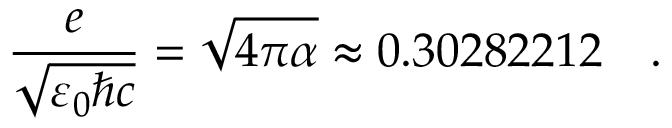<formula> <loc_0><loc_0><loc_500><loc_500>{ \frac { e } { \sqrt { \varepsilon _ { 0 } \hbar { c } } } } = { \sqrt { 4 \pi \alpha } } \approx 0 . 3 0 2 8 2 2 1 2 \ .</formula> 